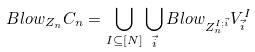Convert formula to latex. <formula><loc_0><loc_0><loc_500><loc_500>B l o w _ { Z _ { n } } C _ { n } & = \bigcup _ { I \subseteq [ N ] } \bigcup _ { \vec { i } } B l o w _ { Z _ { n } ^ { I ; \vec { i } } } V ^ { I } _ { \vec { i } }</formula> 